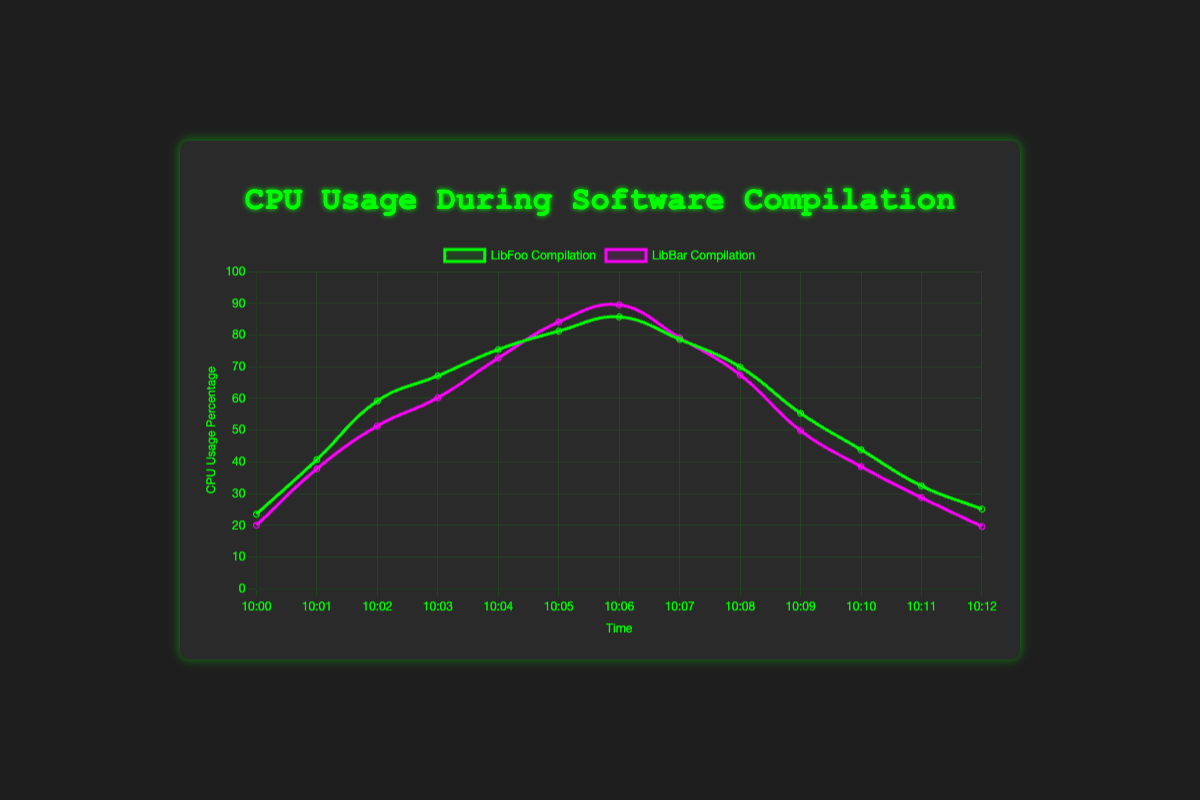What time does LibFoo Compilation reach its peak CPU usage? The LibFoo Compilation reaches its peak CPU usage at 85.7% at the timestamp 10:06. You can determine this by locating the highest value on the 'LibFoo Compilation' data series.
Answer: 10:06 Which compilation, LibFoo or LibBar, has a higher peak CPU usage, and what is it? The `LibBar Compilation` has a higher peak CPU usage. To find this, compare the peak values of both series. LibBar reaches 89.5% at 10:06, while LibFoo has a peak of 85.7% at the same time.
Answer: LibBar, 89.5% During the compilation of LibFoo, by how much does the CPU usage increase from 10:00 to 10:06? At 10:00, the CPU usage for LibFoo is 23.5%, and at 10:06, it is 85.7%. To find the increase, subtract the initial usage from the final usage: 85.7% - 23.5% = 62.2%.
Answer: 62.2% Which project has a steeper initial increase in CPU usage in the first two minutes, and by how much? For LibFoo, the initial increase from 10:00 (23.5%) to 10:02 (59.2%) is 35.7%. For LibBar, the increase from 10:00 (20.0%) to 10:02 (51.3%) is 31.3%. LibFoo has a steeper initial increase by 35.7% - 31.3% = 4.4%.
Answer: LibFoo, 4.4% What is the average CPU usage for LibBar Compilation from 10:00 to 10:06? Sum the CPU usage percentages for LibBar from 10:00 to 10:06 (20.0 + 37.8 + 51.3 + 60.2 + 72.7 + 84.1 + 89.5) = 415.6. Then, divide by the number of data points (7): 415.6 / 7 = 59.37%.
Answer: 59.37% At 10:05, by how much does LibBar's CPU usage exceed LibFoo's? At 10:05, LibFoo's CPU usage is 81.2%, and LibBar's is 84.1%. The difference is 84.1% - 81.2% = 2.9%.
Answer: 2.9% What visual color represents the LibBar Compilation in the plot? The visual representation of LibBar Compilation is indicated by a purple line and shaded area. This helps differentiate it from the green color used for LibFoo.
Answer: purple For how long does the CPU usage stay above 70% for both LibFoo and LibBar compilations? For LibFoo, the CPU usage is above 70% from 10:04 to 10:07, which is 3 minutes. For LibBar, it is above 70% from 10:04 to 10:08, which is 4 minutes. Total combined duration is 7 minutes.
Answer: 7 minutes Which compilation shows a sharper drop in CPU usage after peaking, and how much is the drop? LibBar's CPU usage drops from 89.5% at 10:06 to 79.1% at 10:07, a drop of 10.4%. LibFoo's drops from 85.7% at 10:06 to 78.6% at 10:07, a drop of 7.1%. Thus, LibBar shows a sharper drop of 10.4%.
Answer: LibBar, 10.4% 